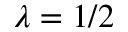<formula> <loc_0><loc_0><loc_500><loc_500>\lambda = 1 / 2</formula> 